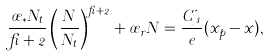<formula> <loc_0><loc_0><loc_500><loc_500>\frac { \sigma _ { \ast } N _ { t } } { \beta + 2 } \left ( \frac { N } { N _ { t } } \right ) ^ { \beta + 2 } + \sigma _ { r } N = \frac { C j _ { s } } { e } ( x _ { p } - x ) ,</formula> 